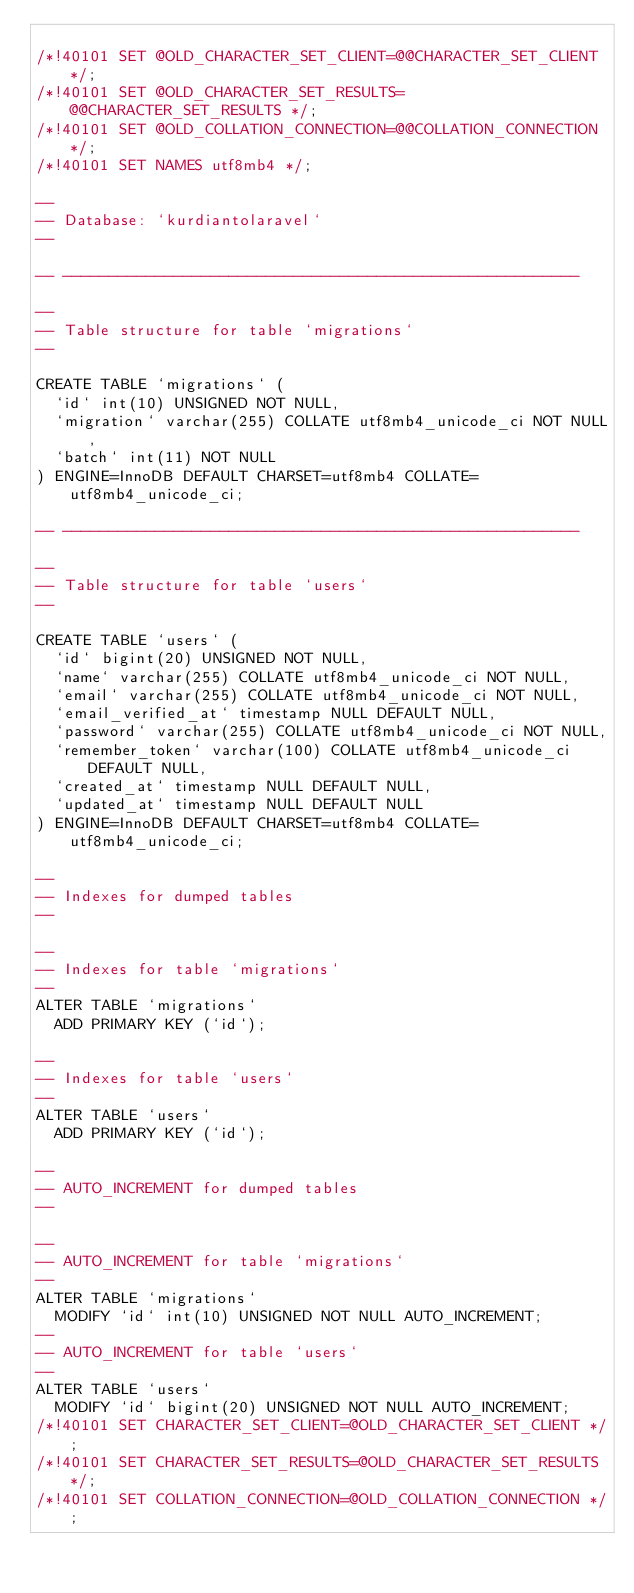<code> <loc_0><loc_0><loc_500><loc_500><_SQL_>
/*!40101 SET @OLD_CHARACTER_SET_CLIENT=@@CHARACTER_SET_CLIENT */;
/*!40101 SET @OLD_CHARACTER_SET_RESULTS=@@CHARACTER_SET_RESULTS */;
/*!40101 SET @OLD_COLLATION_CONNECTION=@@COLLATION_CONNECTION */;
/*!40101 SET NAMES utf8mb4 */;

--
-- Database: `kurdiantolaravel`
--

-- --------------------------------------------------------

--
-- Table structure for table `migrations`
--

CREATE TABLE `migrations` (
  `id` int(10) UNSIGNED NOT NULL,
  `migration` varchar(255) COLLATE utf8mb4_unicode_ci NOT NULL,
  `batch` int(11) NOT NULL
) ENGINE=InnoDB DEFAULT CHARSET=utf8mb4 COLLATE=utf8mb4_unicode_ci;

-- --------------------------------------------------------

--
-- Table structure for table `users`
--

CREATE TABLE `users` (
  `id` bigint(20) UNSIGNED NOT NULL,
  `name` varchar(255) COLLATE utf8mb4_unicode_ci NOT NULL,
  `email` varchar(255) COLLATE utf8mb4_unicode_ci NOT NULL,
  `email_verified_at` timestamp NULL DEFAULT NULL,
  `password` varchar(255) COLLATE utf8mb4_unicode_ci NOT NULL,
  `remember_token` varchar(100) COLLATE utf8mb4_unicode_ci DEFAULT NULL,
  `created_at` timestamp NULL DEFAULT NULL,
  `updated_at` timestamp NULL DEFAULT NULL
) ENGINE=InnoDB DEFAULT CHARSET=utf8mb4 COLLATE=utf8mb4_unicode_ci;

--
-- Indexes for dumped tables
--

--
-- Indexes for table `migrations`
--
ALTER TABLE `migrations`
  ADD PRIMARY KEY (`id`);

--
-- Indexes for table `users`
--
ALTER TABLE `users`
  ADD PRIMARY KEY (`id`);

--
-- AUTO_INCREMENT for dumped tables
--

--
-- AUTO_INCREMENT for table `migrations`
--
ALTER TABLE `migrations`
  MODIFY `id` int(10) UNSIGNED NOT NULL AUTO_INCREMENT;
--
-- AUTO_INCREMENT for table `users`
--
ALTER TABLE `users`
  MODIFY `id` bigint(20) UNSIGNED NOT NULL AUTO_INCREMENT;
/*!40101 SET CHARACTER_SET_CLIENT=@OLD_CHARACTER_SET_CLIENT */;
/*!40101 SET CHARACTER_SET_RESULTS=@OLD_CHARACTER_SET_RESULTS */;
/*!40101 SET COLLATION_CONNECTION=@OLD_COLLATION_CONNECTION */;
</code> 